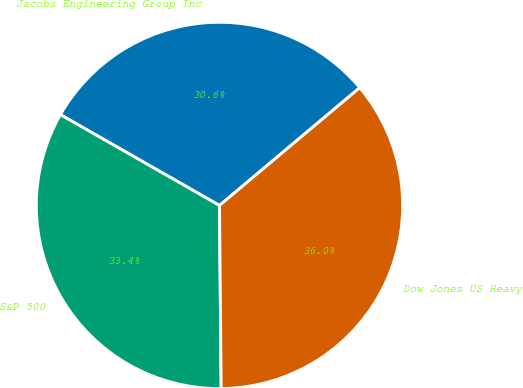Convert chart to OTSL. <chart><loc_0><loc_0><loc_500><loc_500><pie_chart><fcel>Jacobs Engineering Group Inc<fcel>S&P 500<fcel>Dow Jones US Heavy<nl><fcel>30.63%<fcel>33.4%<fcel>35.97%<nl></chart> 